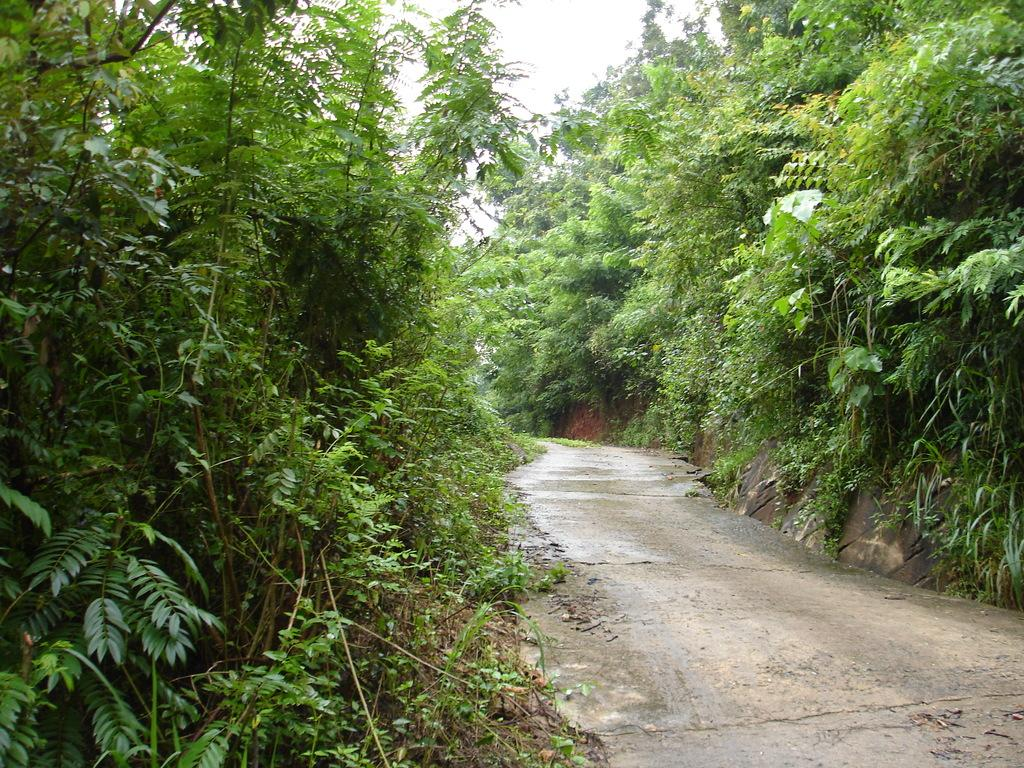What can be seen in the image that people might walk on? There is a path in the image that people might walk on. What type of vegetation is present alongside the path? There are trees on both sides of the path. What type of roof can be seen on the fairies' houses in the image? There are no fairies or houses present in the image, so there is no roof to be seen. 